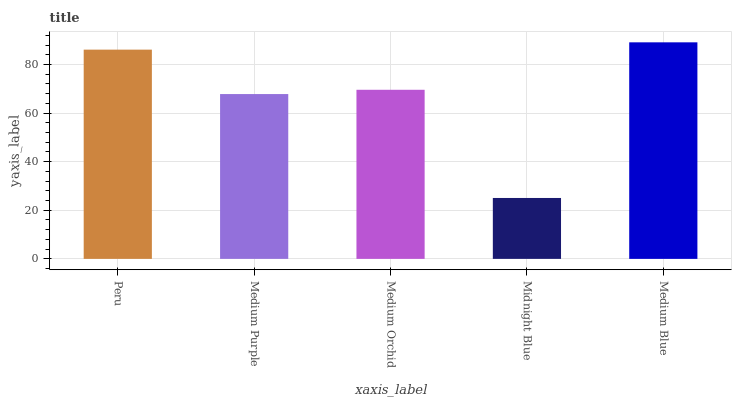Is Medium Purple the minimum?
Answer yes or no. No. Is Medium Purple the maximum?
Answer yes or no. No. Is Peru greater than Medium Purple?
Answer yes or no. Yes. Is Medium Purple less than Peru?
Answer yes or no. Yes. Is Medium Purple greater than Peru?
Answer yes or no. No. Is Peru less than Medium Purple?
Answer yes or no. No. Is Medium Orchid the high median?
Answer yes or no. Yes. Is Medium Orchid the low median?
Answer yes or no. Yes. Is Peru the high median?
Answer yes or no. No. Is Midnight Blue the low median?
Answer yes or no. No. 